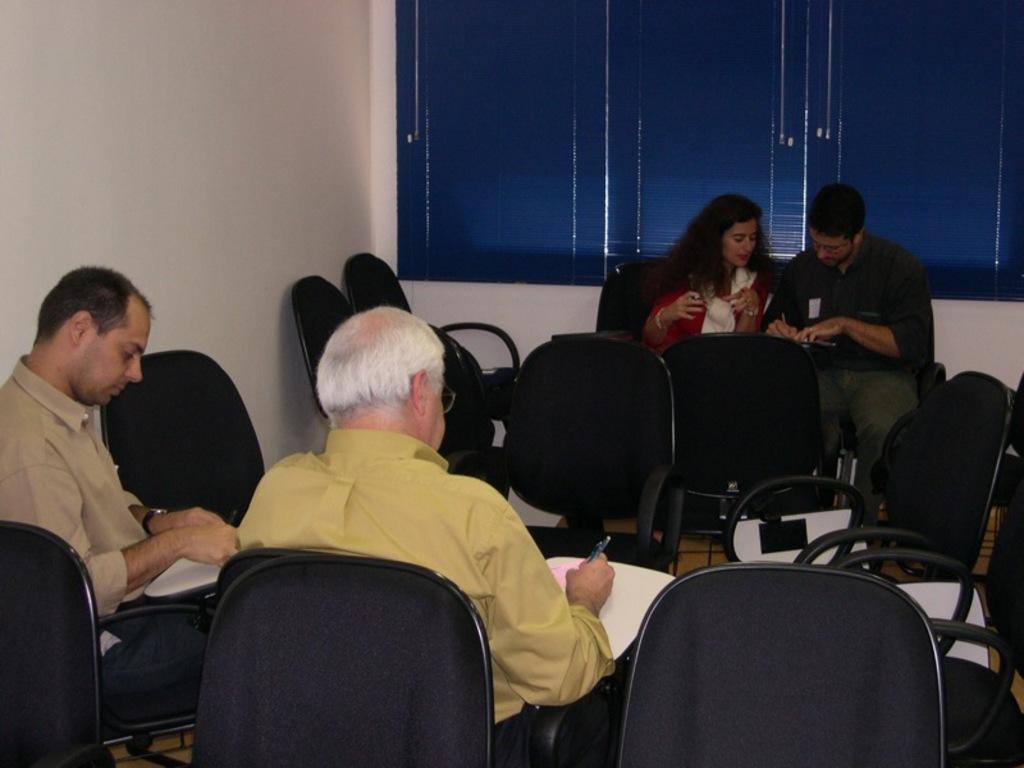Can you describe this image briefly? There are four people sitting in this room. Three of them are men and one of them is woman. Two of them are writing on a paper with a pen. There are some empty chairs in this room. We can observe curtains and wall in the background. 